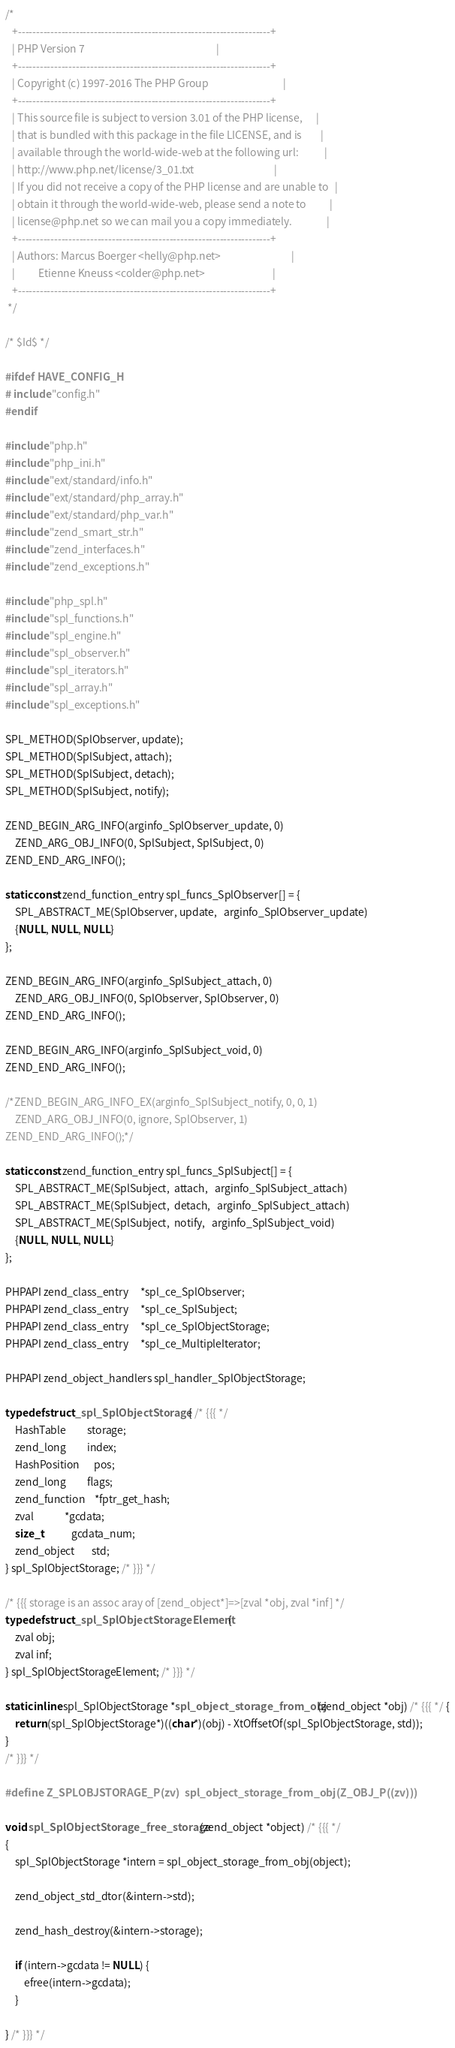<code> <loc_0><loc_0><loc_500><loc_500><_C_>/*
   +----------------------------------------------------------------------+
   | PHP Version 7                                                        |
   +----------------------------------------------------------------------+
   | Copyright (c) 1997-2016 The PHP Group                                |
   +----------------------------------------------------------------------+
   | This source file is subject to version 3.01 of the PHP license,      |
   | that is bundled with this package in the file LICENSE, and is        |
   | available through the world-wide-web at the following url:           |
   | http://www.php.net/license/3_01.txt                                  |
   | If you did not receive a copy of the PHP license and are unable to   |
   | obtain it through the world-wide-web, please send a note to          |
   | license@php.net so we can mail you a copy immediately.               |
   +----------------------------------------------------------------------+
   | Authors: Marcus Boerger <helly@php.net>                              |
   |          Etienne Kneuss <colder@php.net>                             |
   +----------------------------------------------------------------------+
 */

/* $Id$ */

#ifdef HAVE_CONFIG_H
# include "config.h"
#endif

#include "php.h"
#include "php_ini.h"
#include "ext/standard/info.h"
#include "ext/standard/php_array.h"
#include "ext/standard/php_var.h"
#include "zend_smart_str.h"
#include "zend_interfaces.h"
#include "zend_exceptions.h"

#include "php_spl.h"
#include "spl_functions.h"
#include "spl_engine.h"
#include "spl_observer.h"
#include "spl_iterators.h"
#include "spl_array.h"
#include "spl_exceptions.h"

SPL_METHOD(SplObserver, update);
SPL_METHOD(SplSubject, attach);
SPL_METHOD(SplSubject, detach);
SPL_METHOD(SplSubject, notify);

ZEND_BEGIN_ARG_INFO(arginfo_SplObserver_update, 0)
	ZEND_ARG_OBJ_INFO(0, SplSubject, SplSubject, 0)
ZEND_END_ARG_INFO();

static const zend_function_entry spl_funcs_SplObserver[] = {
	SPL_ABSTRACT_ME(SplObserver, update,   arginfo_SplObserver_update)
	{NULL, NULL, NULL}
};

ZEND_BEGIN_ARG_INFO(arginfo_SplSubject_attach, 0)
	ZEND_ARG_OBJ_INFO(0, SplObserver, SplObserver, 0)
ZEND_END_ARG_INFO();

ZEND_BEGIN_ARG_INFO(arginfo_SplSubject_void, 0)
ZEND_END_ARG_INFO();

/*ZEND_BEGIN_ARG_INFO_EX(arginfo_SplSubject_notify, 0, 0, 1)
	ZEND_ARG_OBJ_INFO(0, ignore, SplObserver, 1)
ZEND_END_ARG_INFO();*/

static const zend_function_entry spl_funcs_SplSubject[] = {
	SPL_ABSTRACT_ME(SplSubject,  attach,   arginfo_SplSubject_attach)
	SPL_ABSTRACT_ME(SplSubject,  detach,   arginfo_SplSubject_attach)
	SPL_ABSTRACT_ME(SplSubject,  notify,   arginfo_SplSubject_void)
	{NULL, NULL, NULL}
};

PHPAPI zend_class_entry     *spl_ce_SplObserver;
PHPAPI zend_class_entry     *spl_ce_SplSubject;
PHPAPI zend_class_entry     *spl_ce_SplObjectStorage;
PHPAPI zend_class_entry     *spl_ce_MultipleIterator;

PHPAPI zend_object_handlers spl_handler_SplObjectStorage;

typedef struct _spl_SplObjectStorage { /* {{{ */
	HashTable         storage;
	zend_long         index;
	HashPosition      pos;
	zend_long         flags;
	zend_function    *fptr_get_hash;
	zval             *gcdata;
	size_t            gcdata_num;
	zend_object       std;
} spl_SplObjectStorage; /* }}} */

/* {{{ storage is an assoc aray of [zend_object*]=>[zval *obj, zval *inf] */
typedef struct _spl_SplObjectStorageElement {
	zval obj;
	zval inf;
} spl_SplObjectStorageElement; /* }}} */

static inline spl_SplObjectStorage *spl_object_storage_from_obj(zend_object *obj) /* {{{ */ {
	return (spl_SplObjectStorage*)((char*)(obj) - XtOffsetOf(spl_SplObjectStorage, std));
}
/* }}} */

#define Z_SPLOBJSTORAGE_P(zv)  spl_object_storage_from_obj(Z_OBJ_P((zv)))

void spl_SplObjectStorage_free_storage(zend_object *object) /* {{{ */
{
	spl_SplObjectStorage *intern = spl_object_storage_from_obj(object);

	zend_object_std_dtor(&intern->std);

	zend_hash_destroy(&intern->storage);

	if (intern->gcdata != NULL) {
		efree(intern->gcdata);
	}

} /* }}} */
</code> 